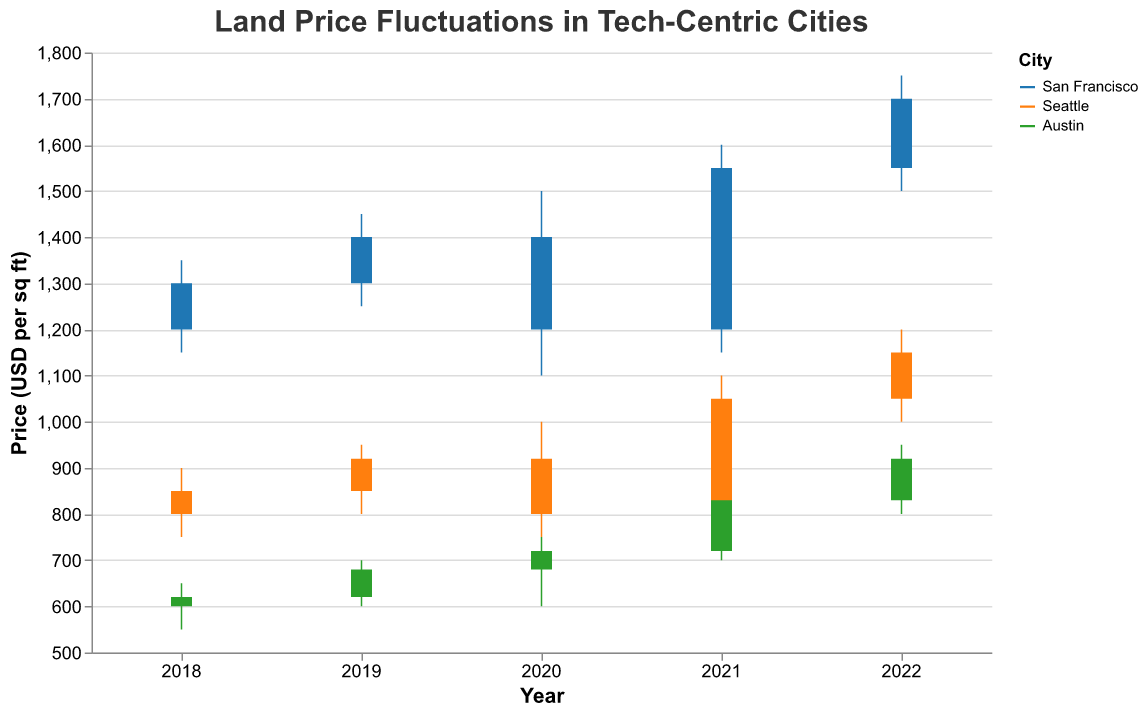What is the title of the figure? The title of the figure is displayed at the top and reads "Land Price Fluctuations in Tech-Centric Cities".
Answer: Land Price Fluctuations in Tech-Centric Cities Which city had the highest land price in 2022? By examining the data, the highest price in 2022 is indicated with a peak in the bar representing "High" value. For 2022, San Francisco has the highest value at 1750.
Answer: San Francisco Between 2020 and 2021, how did the closing price for Seattle change? The closing price for Seattle in 2020 was 800, and in 2021 it was 1050. The change is calculated as 1050 - 800 = 250.
Answer: Increased by 250 What was the lowest land price in 2021 for Austin? The lowest price for Austin in 2021 is indicated by the "Low" value in the plot for that year. The value is 700.
Answer: 700 How much did the opening price for San Francisco increase from 2018 to 2022? San Francisco's opening price in 2018 was 1200, and in 2022 it was 1550. The increase is calculated as 1550 - 1200 = 350.
Answer: 350 Which year had the most significant fluctuation in land prices for Seattle? Looking at the range between "High" and "Low" values for each year for Seattle, 2021 had the biggest fluctuation. The range for 2021 was 1100 - 780 = 320.
Answer: 2021 Compare the closing land prices between Austin and San Francisco in 2019. Which city had a higher price and by how much? In 2019, the closing price for Austin was 680, and for San Francisco, it was 1400. The difference is 1400 - 680 = 720, with San Francisco having a higher price.
Answer: San Francisco, by 720 What is the overall trend in closing prices for San Francisco from 2018 to 2022? Analyzing the closing prices for each year (2018: 1300, 2019: 1400, 2020: 1200, 2021: 1550, 2022: 1700), the overall trend shows an increase in prices over the years, despite a dip in 2020.
Answer: Increasing trend Among the three cities, which had the least variation in land prices in 2020, and what was the variation? By examining the difference between "High" and "Low" for each city in 2020, Austin had the least variation with a range of 750 - 600 = 150.
Answer: Austin, 150 What was the closing price for Austin in 2018, and how did it compare to the closing price in 2022? The closing price for Austin in 2018 was 620, and in 2022 it was 920. The difference is 920 - 620 = 300, indicating an increase.
Answer: 620 in 2018, increased by 300 in 2022 